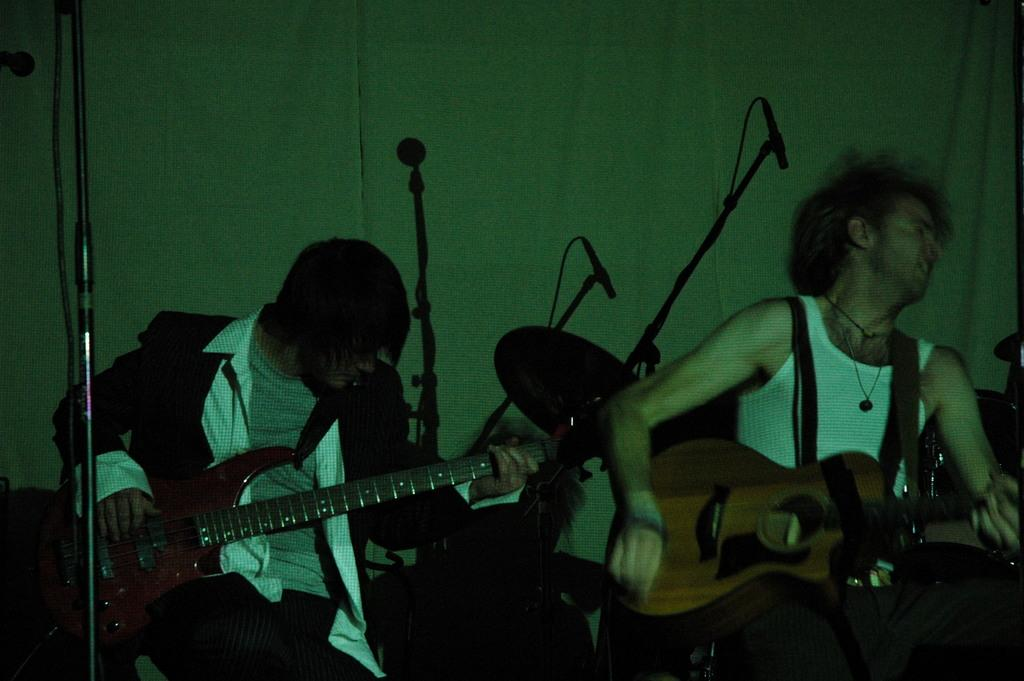How many people are in the image? There are two men in the image. What are the men doing in the image? The men are playing guitars. What is in front of the men in the image? There is a pole in front of the men. What can be seen in the background of the image? There are mic stands and a drum kit in the background. What type of kite is the man holding in the image? There is no kite present in the image; the men are playing guitars. What is the weight of the suit the man is wearing in the image? There is no suit present in the image, and therefore, no weight can be determined. 